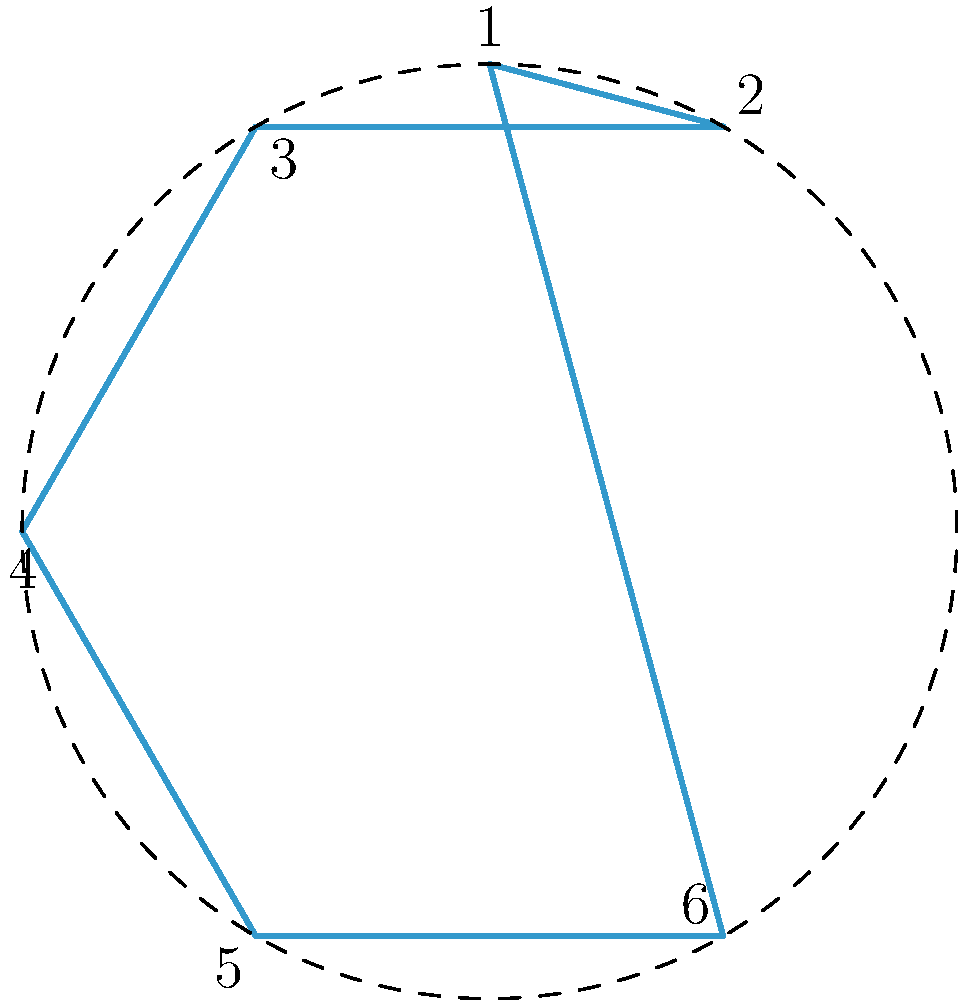Consider the dihedral group $D_6$, which represents the symmetries of a regular hexagon. If we apply a rotation of 60° clockwise followed by a reflection across the vertical axis, what is the resulting permutation of the vertices in cycle notation? Let's approach this step-by-step:

1) First, let's consider the rotation of 60° clockwise:
   This moves each vertex to the position of the next vertex clockwise.
   1 → 6, 2 → 1, 3 → 2, 4 → 3, 5 → 4, 6 → 5
   In cycle notation, this is (123456).

2) Now, let's apply the reflection across the vertical axis:
   This swaps vertices across the vertical axis.
   1 ↔ 1, 2 ↔ 6, 3 ↔ 5, 4 ↔ 4
   In cycle notation, this is (26)(35).

3) To find the overall effect, we apply these operations in order (rotation first, then reflection):
   
   Starting with 1: 1 → 6 → 6
   Starting with 2: 2 → 1 → 1
   Starting with 3: 3 → 2 → 6
   Starting with 4: 4 → 3 → 5
   Starting with 5: 5 → 4 → 4
   Starting with 6: 6 → 5 → 3

4) Writing this as a permutation in cycle notation:
   (12)(3654)

Therefore, the resulting permutation is (12)(3654).
Answer: (12)(3654) 